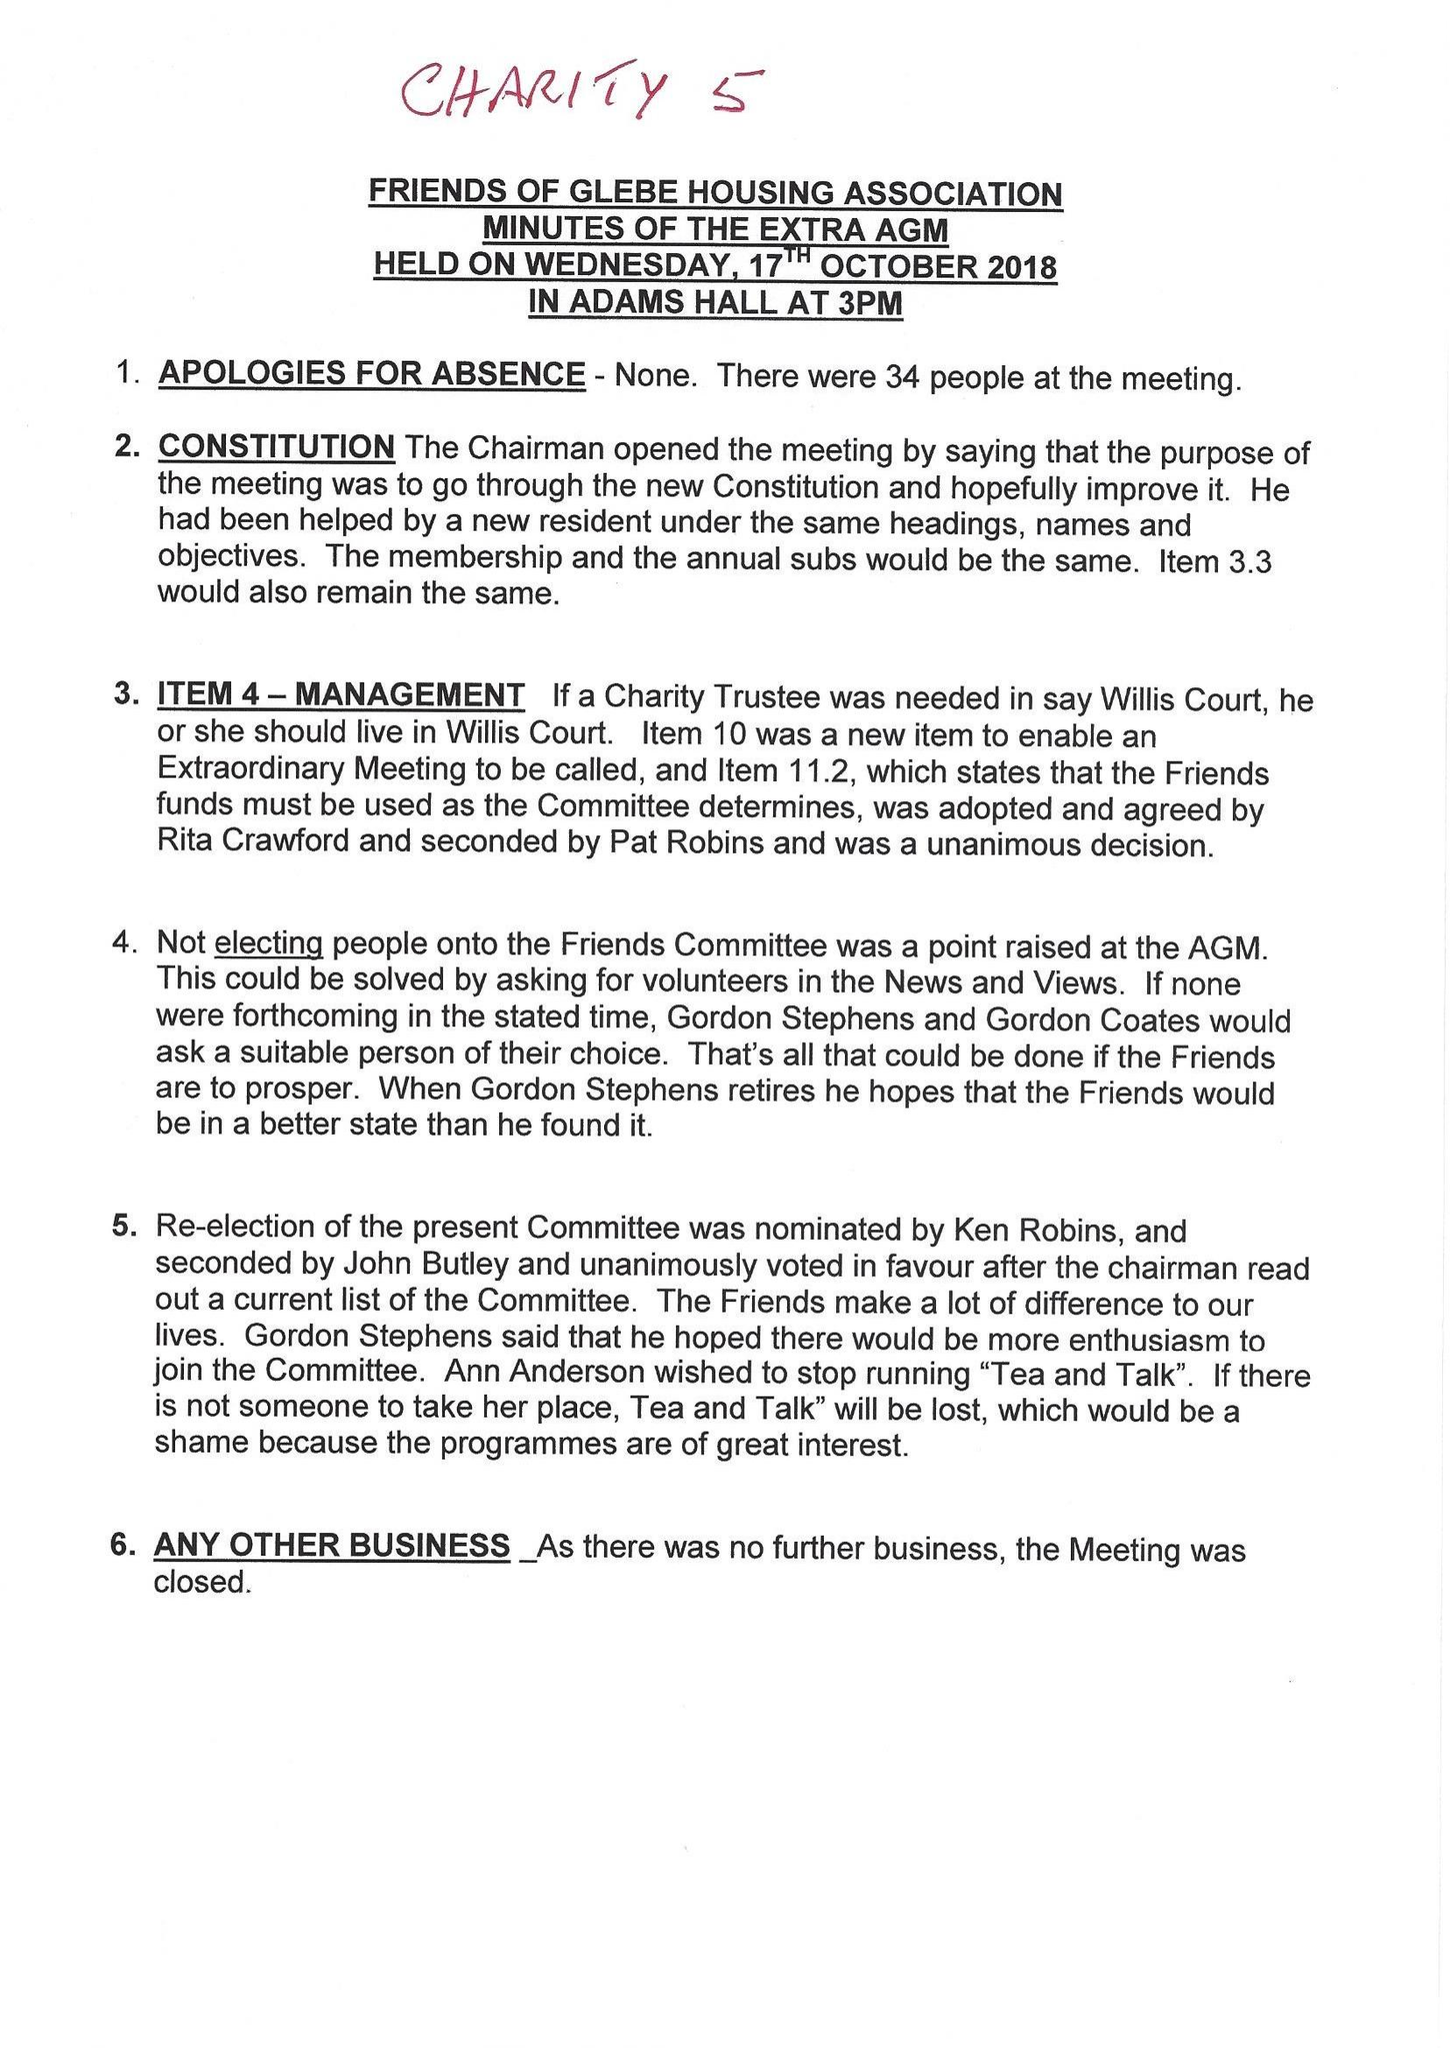What is the value for the charity_number?
Answer the question using a single word or phrase. 293621 